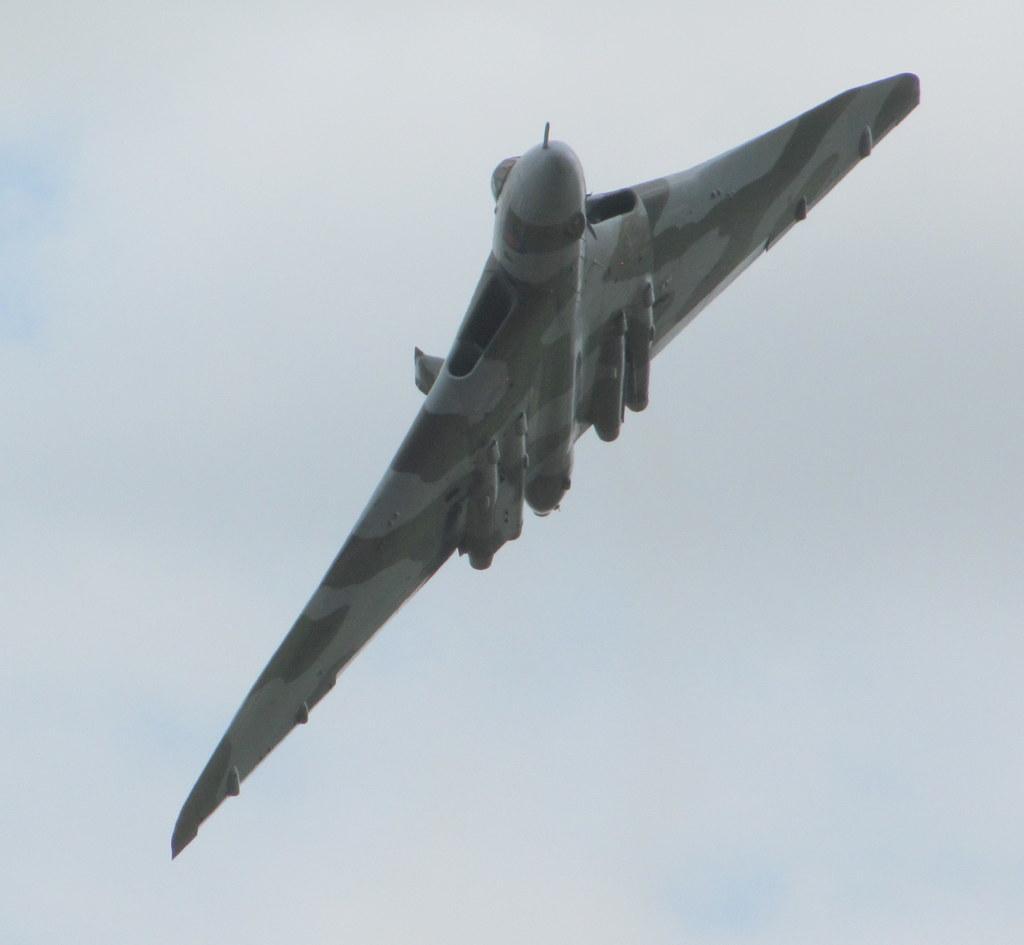In one or two sentences, can you explain what this image depicts? In this image I can see an aircraft. Behind it, we can see the clear sky. 